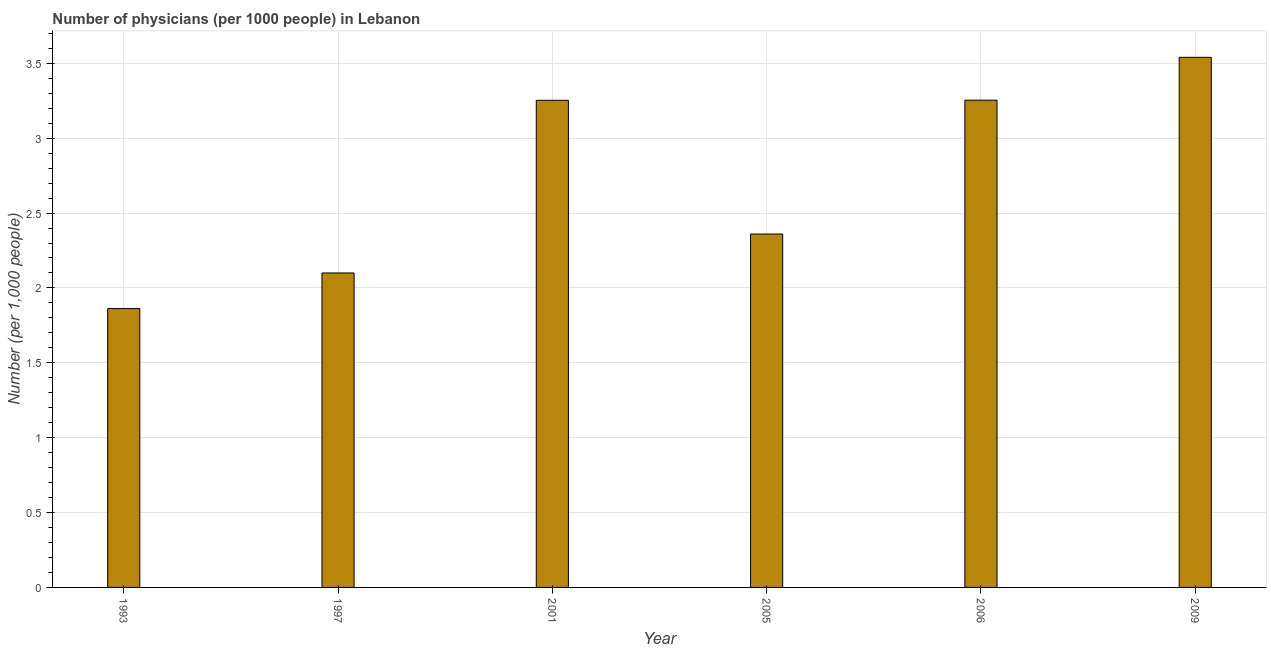Does the graph contain any zero values?
Offer a terse response. No. Does the graph contain grids?
Provide a short and direct response. Yes. What is the title of the graph?
Offer a terse response. Number of physicians (per 1000 people) in Lebanon. What is the label or title of the Y-axis?
Make the answer very short. Number (per 1,0 people). What is the number of physicians in 2006?
Your response must be concise. 3.25. Across all years, what is the maximum number of physicians?
Your answer should be compact. 3.54. Across all years, what is the minimum number of physicians?
Your answer should be very brief. 1.86. What is the sum of the number of physicians?
Your response must be concise. 16.37. What is the difference between the number of physicians in 2001 and 2009?
Offer a terse response. -0.29. What is the average number of physicians per year?
Ensure brevity in your answer.  2.73. What is the median number of physicians?
Your answer should be compact. 2.81. What is the ratio of the number of physicians in 1993 to that in 2009?
Your answer should be compact. 0.53. Is the number of physicians in 2001 less than that in 2006?
Give a very brief answer. Yes. What is the difference between the highest and the second highest number of physicians?
Your response must be concise. 0.29. Is the sum of the number of physicians in 1993 and 2006 greater than the maximum number of physicians across all years?
Provide a succinct answer. Yes. What is the difference between the highest and the lowest number of physicians?
Keep it short and to the point. 1.68. In how many years, is the number of physicians greater than the average number of physicians taken over all years?
Your response must be concise. 3. Are all the bars in the graph horizontal?
Ensure brevity in your answer.  No. How many years are there in the graph?
Keep it short and to the point. 6. Are the values on the major ticks of Y-axis written in scientific E-notation?
Your answer should be very brief. No. What is the Number (per 1,000 people) of 1993?
Offer a very short reply. 1.86. What is the Number (per 1,000 people) of 1997?
Provide a short and direct response. 2.1. What is the Number (per 1,000 people) in 2001?
Give a very brief answer. 3.25. What is the Number (per 1,000 people) of 2005?
Provide a succinct answer. 2.36. What is the Number (per 1,000 people) of 2006?
Offer a terse response. 3.25. What is the Number (per 1,000 people) in 2009?
Your answer should be very brief. 3.54. What is the difference between the Number (per 1,000 people) in 1993 and 1997?
Your answer should be compact. -0.24. What is the difference between the Number (per 1,000 people) in 1993 and 2001?
Your response must be concise. -1.39. What is the difference between the Number (per 1,000 people) in 1993 and 2005?
Your answer should be compact. -0.5. What is the difference between the Number (per 1,000 people) in 1993 and 2006?
Make the answer very short. -1.39. What is the difference between the Number (per 1,000 people) in 1993 and 2009?
Offer a very short reply. -1.68. What is the difference between the Number (per 1,000 people) in 1997 and 2001?
Offer a very short reply. -1.15. What is the difference between the Number (per 1,000 people) in 1997 and 2005?
Ensure brevity in your answer.  -0.26. What is the difference between the Number (per 1,000 people) in 1997 and 2006?
Ensure brevity in your answer.  -1.15. What is the difference between the Number (per 1,000 people) in 1997 and 2009?
Give a very brief answer. -1.44. What is the difference between the Number (per 1,000 people) in 2001 and 2005?
Provide a short and direct response. 0.89. What is the difference between the Number (per 1,000 people) in 2001 and 2006?
Your response must be concise. -0. What is the difference between the Number (per 1,000 people) in 2001 and 2009?
Your answer should be compact. -0.29. What is the difference between the Number (per 1,000 people) in 2005 and 2006?
Give a very brief answer. -0.89. What is the difference between the Number (per 1,000 people) in 2005 and 2009?
Your response must be concise. -1.18. What is the difference between the Number (per 1,000 people) in 2006 and 2009?
Provide a short and direct response. -0.29. What is the ratio of the Number (per 1,000 people) in 1993 to that in 1997?
Offer a terse response. 0.89. What is the ratio of the Number (per 1,000 people) in 1993 to that in 2001?
Keep it short and to the point. 0.57. What is the ratio of the Number (per 1,000 people) in 1993 to that in 2005?
Your answer should be compact. 0.79. What is the ratio of the Number (per 1,000 people) in 1993 to that in 2006?
Provide a succinct answer. 0.57. What is the ratio of the Number (per 1,000 people) in 1993 to that in 2009?
Provide a succinct answer. 0.53. What is the ratio of the Number (per 1,000 people) in 1997 to that in 2001?
Ensure brevity in your answer.  0.65. What is the ratio of the Number (per 1,000 people) in 1997 to that in 2005?
Ensure brevity in your answer.  0.89. What is the ratio of the Number (per 1,000 people) in 1997 to that in 2006?
Offer a very short reply. 0.65. What is the ratio of the Number (per 1,000 people) in 1997 to that in 2009?
Your response must be concise. 0.59. What is the ratio of the Number (per 1,000 people) in 2001 to that in 2005?
Provide a short and direct response. 1.38. What is the ratio of the Number (per 1,000 people) in 2001 to that in 2009?
Keep it short and to the point. 0.92. What is the ratio of the Number (per 1,000 people) in 2005 to that in 2006?
Your response must be concise. 0.72. What is the ratio of the Number (per 1,000 people) in 2005 to that in 2009?
Your response must be concise. 0.67. What is the ratio of the Number (per 1,000 people) in 2006 to that in 2009?
Your answer should be very brief. 0.92. 